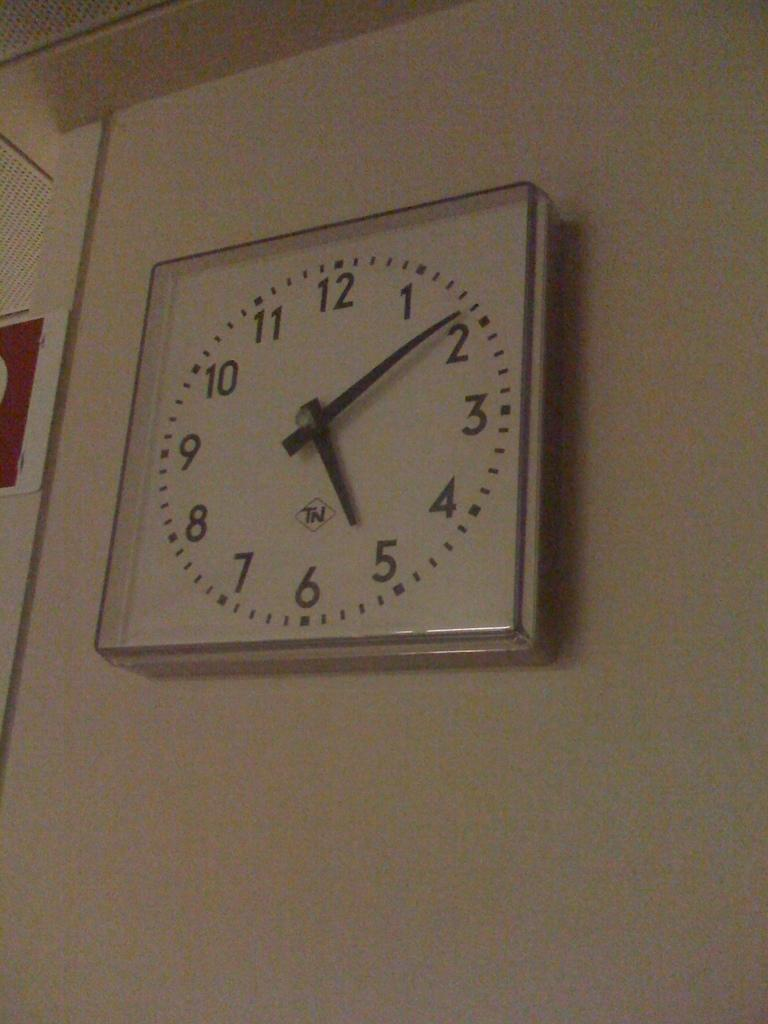<image>
Create a compact narrative representing the image presented. wall clock displaying the time five o'clock and nine minutes 